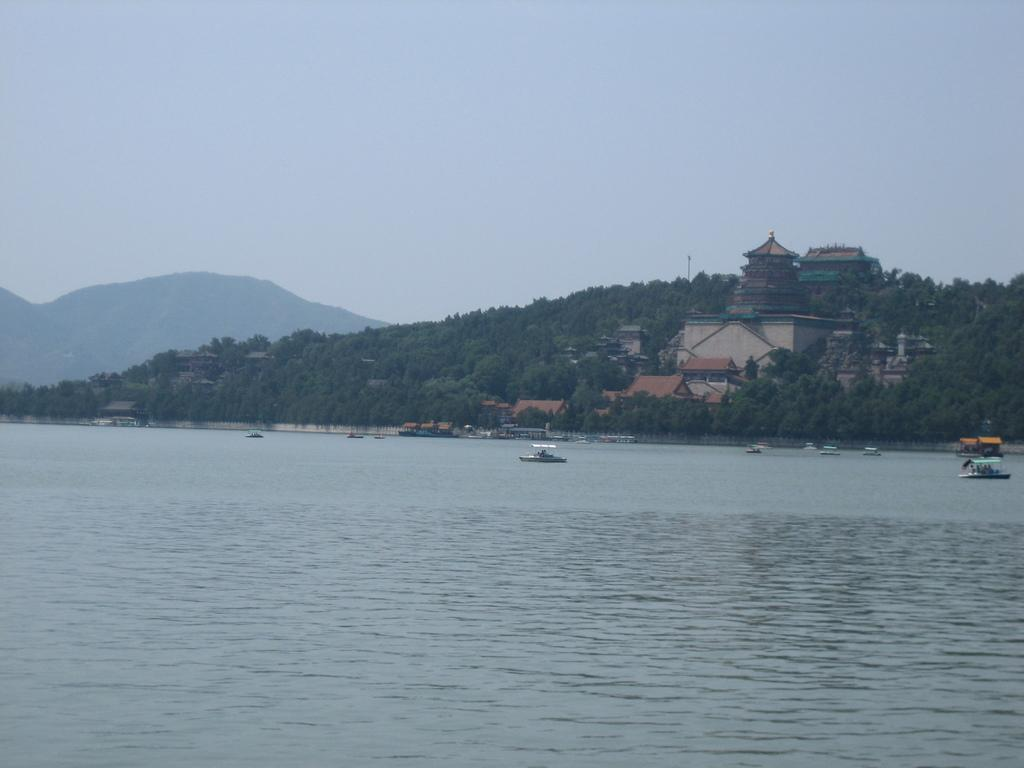What is in the water in the image? There are boats in the water in the image. What type of vegetation can be seen in the image? There are trees visible in the image. What structures are visible in the background? There are buildings in the background. What type of geographical feature is visible in the background? There are hills in the background. What part of the natural environment is visible in the image? The sky is visible in the image. What is the relation between the boats and the trees in the image? There is no specific relation between the boats and the trees mentioned in the image; they are simply two separate elements in the scene. How does one show respect to the boats in the image? There is no indication in the image that respect is required or expected for the boats; they are simply objects in the scene. 